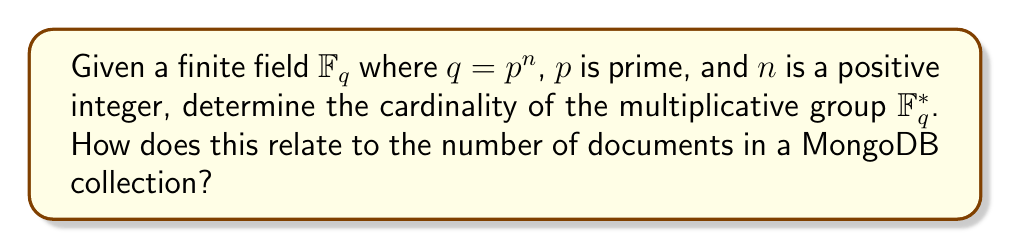Solve this math problem. Let's approach this step-by-step:

1) In a finite field $\mathbb{F}_q$, $q$ represents the total number of elements in the field, where $q = p^n$, $p$ is prime, and $n$ is a positive integer.

2) The multiplicative group $\mathbb{F}_q^*$ consists of all non-zero elements in $\mathbb{F}_q$.

3) Since 0 is not included in the multiplicative group, we subtract 1 from the total number of elements:

   $$|\mathbb{F}_q^*| = q - 1 = p^n - 1$$

4) This means that the multiplicative group $\mathbb{F}_q^*$ has $p^n - 1$ elements.

5) In the context of MongoDB:
   - The cardinality of $\mathbb{F}_q^*$ can be likened to the number of documents in a MongoDB collection, minus one (to account for the difference between including and excluding zero).
   - If we consider $p^n$ as the maximum number of documents a collection can hold (similar to a fixed-size array in traditional databases), then $p^n - 1$ would represent the maximum number of non-empty documents.

6) In practice, MongoDB doesn't have this kind of limitation, but the analogy helps to connect the concept of cardinality in finite fields to database capacity.
Answer: $p^n - 1$ 